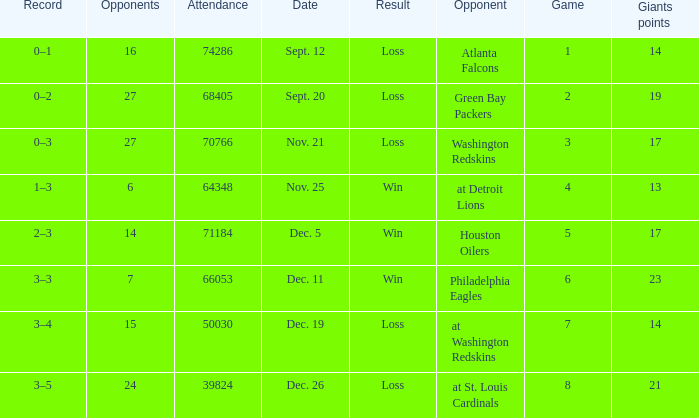What is the minimum number of opponents? 6.0. 